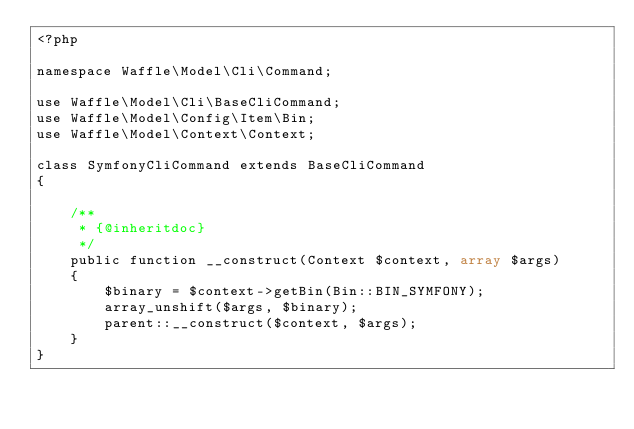Convert code to text. <code><loc_0><loc_0><loc_500><loc_500><_PHP_><?php

namespace Waffle\Model\Cli\Command;

use Waffle\Model\Cli\BaseCliCommand;
use Waffle\Model\Config\Item\Bin;
use Waffle\Model\Context\Context;

class SymfonyCliCommand extends BaseCliCommand
{

    /**
     * {@inheritdoc}
     */
    public function __construct(Context $context, array $args)
    {
        $binary = $context->getBin(Bin::BIN_SYMFONY);
        array_unshift($args, $binary);
        parent::__construct($context, $args);
    }
}
</code> 